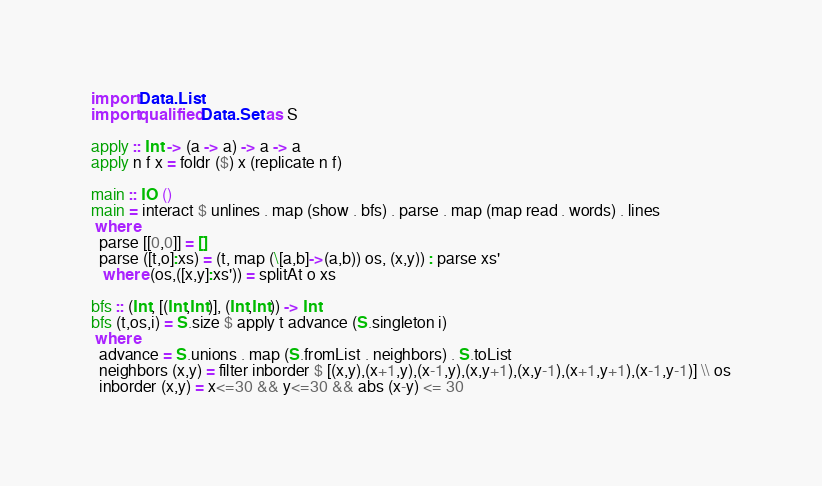Convert code to text. <code><loc_0><loc_0><loc_500><loc_500><_Haskell_>import Data.List
import qualified Data.Set as S

apply :: Int -> (a -> a) -> a -> a
apply n f x = foldr ($) x (replicate n f)

main :: IO ()
main = interact $ unlines . map (show . bfs) . parse . map (map read . words) . lines
 where
  parse [[0,0]] = []
  parse ([t,o]:xs) = (t, map (\[a,b]->(a,b)) os, (x,y)) : parse xs'
   where (os,([x,y]:xs')) = splitAt o xs

bfs :: (Int, [(Int,Int)], (Int,Int)) -> Int
bfs (t,os,i) = S.size $ apply t advance (S.singleton i)
 where
  advance = S.unions . map (S.fromList . neighbors) . S.toList 
  neighbors (x,y) = filter inborder $ [(x,y),(x+1,y),(x-1,y),(x,y+1),(x,y-1),(x+1,y+1),(x-1,y-1)] \\ os
  inborder (x,y) = x<=30 && y<=30 && abs (x-y) <= 30</code> 